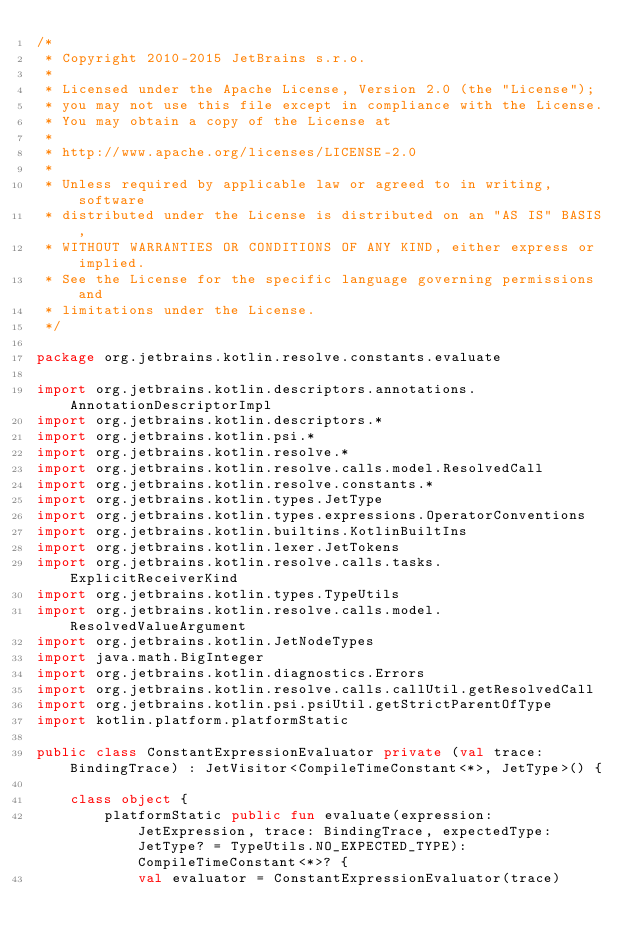Convert code to text. <code><loc_0><loc_0><loc_500><loc_500><_Kotlin_>/*
 * Copyright 2010-2015 JetBrains s.r.o.
 *
 * Licensed under the Apache License, Version 2.0 (the "License");
 * you may not use this file except in compliance with the License.
 * You may obtain a copy of the License at
 *
 * http://www.apache.org/licenses/LICENSE-2.0
 *
 * Unless required by applicable law or agreed to in writing, software
 * distributed under the License is distributed on an "AS IS" BASIS,
 * WITHOUT WARRANTIES OR CONDITIONS OF ANY KIND, either express or implied.
 * See the License for the specific language governing permissions and
 * limitations under the License.
 */

package org.jetbrains.kotlin.resolve.constants.evaluate

import org.jetbrains.kotlin.descriptors.annotations.AnnotationDescriptorImpl
import org.jetbrains.kotlin.descriptors.*
import org.jetbrains.kotlin.psi.*
import org.jetbrains.kotlin.resolve.*
import org.jetbrains.kotlin.resolve.calls.model.ResolvedCall
import org.jetbrains.kotlin.resolve.constants.*
import org.jetbrains.kotlin.types.JetType
import org.jetbrains.kotlin.types.expressions.OperatorConventions
import org.jetbrains.kotlin.builtins.KotlinBuiltIns
import org.jetbrains.kotlin.lexer.JetTokens
import org.jetbrains.kotlin.resolve.calls.tasks.ExplicitReceiverKind
import org.jetbrains.kotlin.types.TypeUtils
import org.jetbrains.kotlin.resolve.calls.model.ResolvedValueArgument
import org.jetbrains.kotlin.JetNodeTypes
import java.math.BigInteger
import org.jetbrains.kotlin.diagnostics.Errors
import org.jetbrains.kotlin.resolve.calls.callUtil.getResolvedCall
import org.jetbrains.kotlin.psi.psiUtil.getStrictParentOfType
import kotlin.platform.platformStatic

public class ConstantExpressionEvaluator private (val trace: BindingTrace) : JetVisitor<CompileTimeConstant<*>, JetType>() {

    class object {
        platformStatic public fun evaluate(expression: JetExpression, trace: BindingTrace, expectedType: JetType? = TypeUtils.NO_EXPECTED_TYPE): CompileTimeConstant<*>? {
            val evaluator = ConstantExpressionEvaluator(trace)</code> 